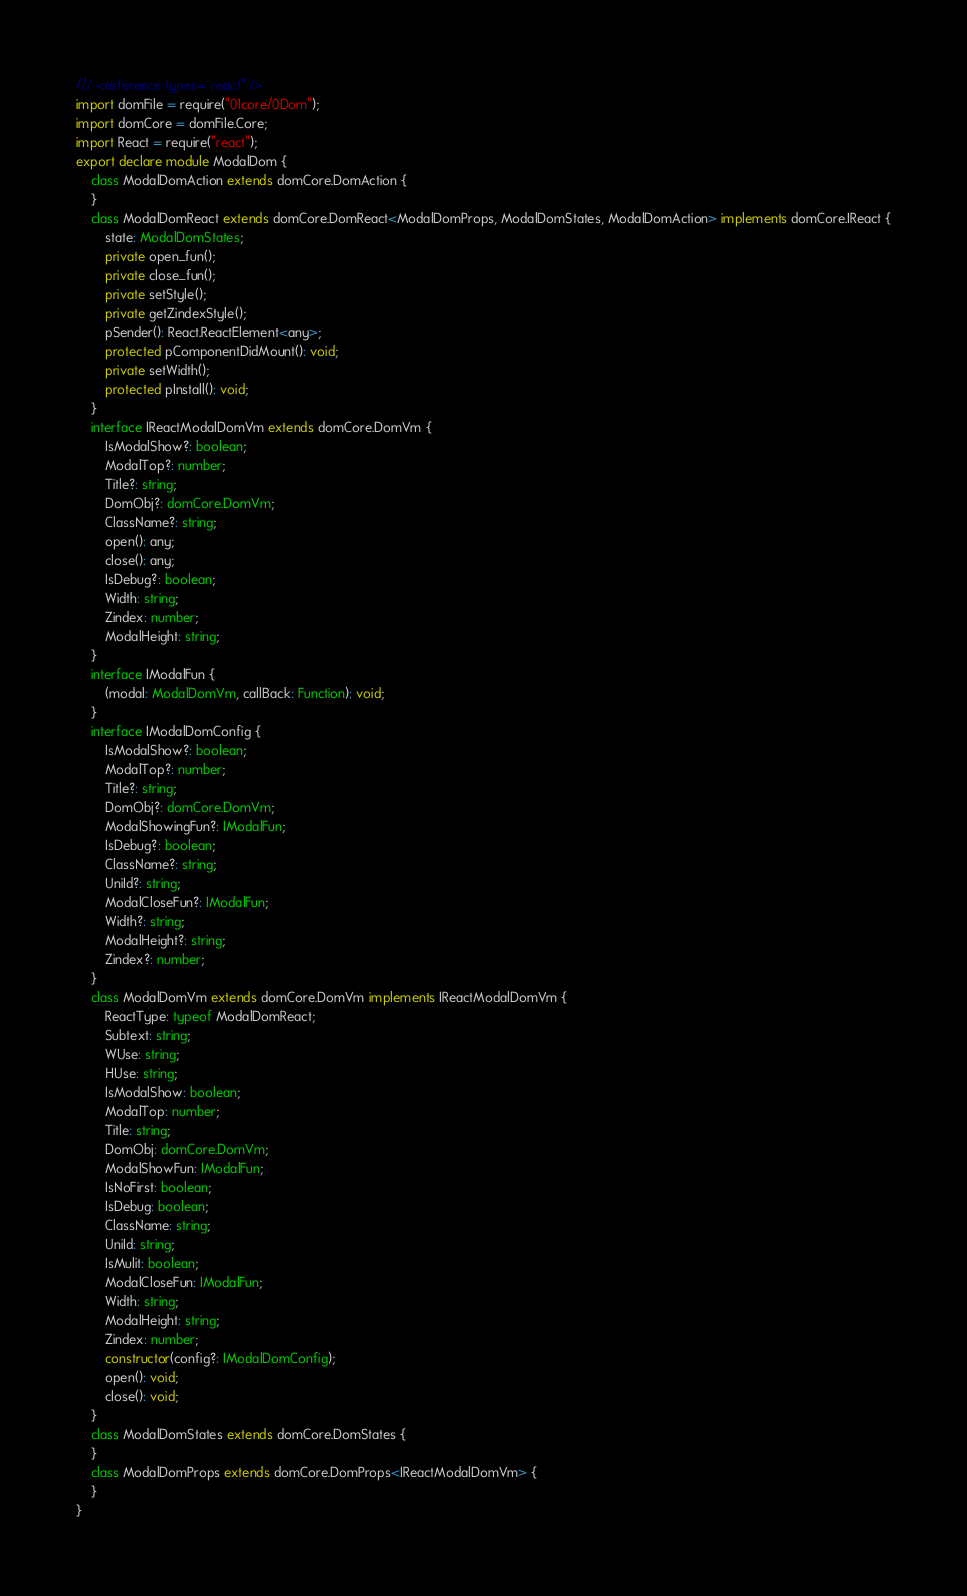<code> <loc_0><loc_0><loc_500><loc_500><_TypeScript_>/// <reference types="react" />
import domFile = require("01core/0Dom");
import domCore = domFile.Core;
import React = require("react");
export declare module ModalDom {
    class ModalDomAction extends domCore.DomAction {
    }
    class ModalDomReact extends domCore.DomReact<ModalDomProps, ModalDomStates, ModalDomAction> implements domCore.IReact {
        state: ModalDomStates;
        private open_fun();
        private close_fun();
        private setStyle();
        private getZindexStyle();
        pSender(): React.ReactElement<any>;
        protected pComponentDidMount(): void;
        private setWidth();
        protected pInstall(): void;
    }
    interface IReactModalDomVm extends domCore.DomVm {
        IsModalShow?: boolean;
        ModalTop?: number;
        Title?: string;
        DomObj?: domCore.DomVm;
        ClassName?: string;
        open(): any;
        close(): any;
        IsDebug?: boolean;
        Width: string;
        Zindex: number;
        ModalHeight: string;
    }
    interface IModalFun {
        (modal: ModalDomVm, callBack: Function): void;
    }
    interface IModalDomConfig {
        IsModalShow?: boolean;
        ModalTop?: number;
        Title?: string;
        DomObj?: domCore.DomVm;
        ModalShowingFun?: IModalFun;
        IsDebug?: boolean;
        ClassName?: string;
        UniId?: string;
        ModalCloseFun?: IModalFun;
        Width?: string;
        ModalHeight?: string;
        Zindex?: number;
    }
    class ModalDomVm extends domCore.DomVm implements IReactModalDomVm {
        ReactType: typeof ModalDomReact;
        Subtext: string;
        WUse: string;
        HUse: string;
        IsModalShow: boolean;
        ModalTop: number;
        Title: string;
        DomObj: domCore.DomVm;
        ModalShowFun: IModalFun;
        IsNoFirst: boolean;
        IsDebug: boolean;
        ClassName: string;
        UniId: string;
        IsMulit: boolean;
        ModalCloseFun: IModalFun;
        Width: string;
        ModalHeight: string;
        Zindex: number;
        constructor(config?: IModalDomConfig);
        open(): void;
        close(): void;
    }
    class ModalDomStates extends domCore.DomStates {
    }
    class ModalDomProps extends domCore.DomProps<IReactModalDomVm> {
    }
}
</code> 